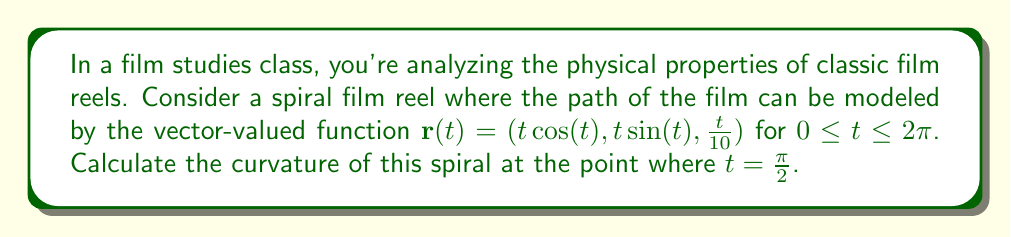Give your solution to this math problem. To calculate the curvature of the spiral film reel, we'll follow these steps:

1) The curvature $\kappa$ is given by the formula:

   $$\kappa = \frac{|\mathbf{r}'(t) \times \mathbf{r}''(t)|}{|\mathbf{r}'(t)|^3}$$

2) First, let's calculate $\mathbf{r}'(t)$:
   $$\mathbf{r}'(t) = (\cos(t) - t\sin(t), \sin(t) + t\cos(t), \frac{1}{10})$$

3) Now, let's calculate $\mathbf{r}''(t)$:
   $$\mathbf{r}''(t) = (-2\sin(t) - t\cos(t), 2\cos(t) - t\sin(t), 0)$$

4) At $t = \frac{\pi}{2}$, these become:
   $$\mathbf{r}'(\frac{\pi}{2}) = (-\frac{\pi}{2}, 1, \frac{1}{10})$$
   $$\mathbf{r}''(\frac{\pi}{2}) = (-1, -\frac{\pi}{2}, 0)$$

5) Now we need to calculate $\mathbf{r}'(\frac{\pi}{2}) \times \mathbf{r}''(\frac{\pi}{2})$:
   $$\mathbf{r}'(\frac{\pi}{2}) \times \mathbf{r}''(\frac{\pi}{2}) = \begin{vmatrix} 
   \mathbf{i} & \mathbf{j} & \mathbf{k} \\
   -\frac{\pi}{2} & 1 & \frac{1}{10} \\
   -1 & -\frac{\pi}{2} & 0
   \end{vmatrix}$$

   $$= (-\frac{1}{10}\cdot(-\frac{\pi}{2}) - \frac{1}{10}, -\frac{\pi}{2}\cdot(-1) - (-\frac{\pi}{2})\cdot(-\frac{\pi}{2}), -\frac{\pi}{2}\cdot(-\frac{\pi}{2}) - 1\cdot1)$$

   $$= (\frac{\pi}{20} - \frac{1}{10}, \frac{\pi}{2} - \frac{\pi^2}{4}, \frac{\pi^2}{4} - 1)$$

6) The magnitude of this cross product is:
   $$|\mathbf{r}'(\frac{\pi}{2}) \times \mathbf{r}''(\frac{\pi}{2})| = \sqrt{(\frac{\pi}{20} - \frac{1}{10})^2 + (\frac{\pi}{2} - \frac{\pi^2}{4})^2 + (\frac{\pi^2}{4} - 1)^2}$$

7) The magnitude of $\mathbf{r}'(\frac{\pi}{2})$ is:
   $$|\mathbf{r}'(\frac{\pi}{2})| = \sqrt{(\frac{\pi}{2})^2 + 1^2 + (\frac{1}{10})^2}$$

8) Therefore, the curvature at $t = \frac{\pi}{2}$ is:
   $$\kappa = \frac{\sqrt{(\frac{\pi}{20} - \frac{1}{10})^2 + (\frac{\pi}{2} - \frac{\pi^2}{4})^2 + (\frac{\pi^2}{4} - 1)^2}}{((\frac{\pi}{2})^2 + 1^2 + (\frac{1}{10})^2)^{3/2}}$$
Answer: $$\kappa = \frac{\sqrt{(\frac{\pi}{20} - \frac{1}{10})^2 + (\frac{\pi}{2} - \frac{\pi^2}{4})^2 + (\frac{\pi^2}{4} - 1)^2}}{((\frac{\pi}{2})^2 + 1^2 + (\frac{1}{10})^2)^{3/2}}$$ 